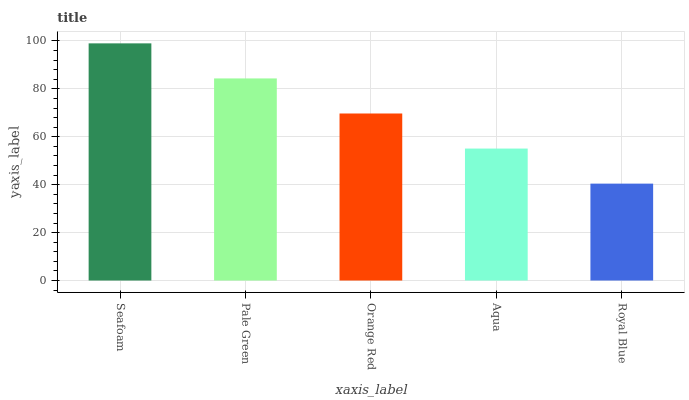Is Pale Green the minimum?
Answer yes or no. No. Is Pale Green the maximum?
Answer yes or no. No. Is Seafoam greater than Pale Green?
Answer yes or no. Yes. Is Pale Green less than Seafoam?
Answer yes or no. Yes. Is Pale Green greater than Seafoam?
Answer yes or no. No. Is Seafoam less than Pale Green?
Answer yes or no. No. Is Orange Red the high median?
Answer yes or no. Yes. Is Orange Red the low median?
Answer yes or no. Yes. Is Aqua the high median?
Answer yes or no. No. Is Seafoam the low median?
Answer yes or no. No. 